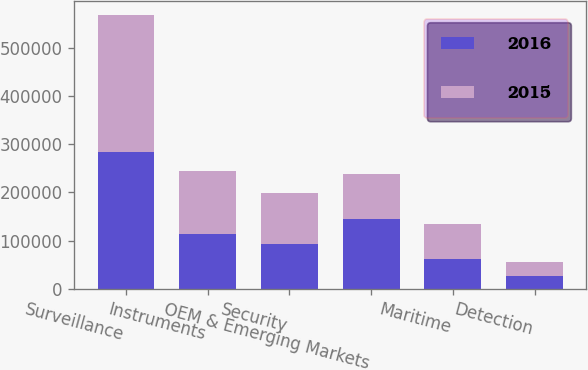Convert chart. <chart><loc_0><loc_0><loc_500><loc_500><stacked_bar_chart><ecel><fcel>Surveillance<fcel>Instruments<fcel>Security<fcel>OEM & Emerging Markets<fcel>Maritime<fcel>Detection<nl><fcel>2016<fcel>283324<fcel>114681<fcel>93174<fcel>144862<fcel>61494<fcel>25856<nl><fcel>2015<fcel>286058<fcel>130135<fcel>105509<fcel>93925<fcel>73506<fcel>30057<nl></chart> 